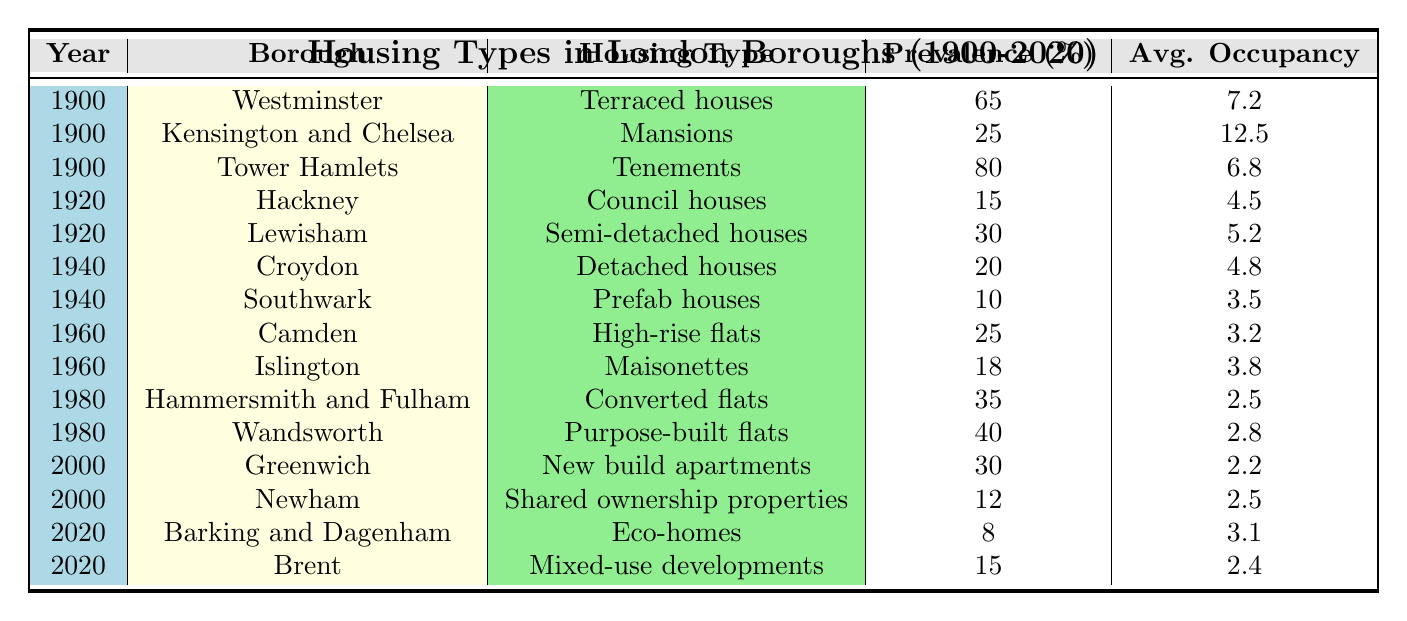What is the most prevalent housing type in Tower Hamlets in 1900? According to the table, in 1900, Tower Hamlets had a prevalence of 80% for Tenements, which is the highest value for that year.
Answer: Tenements In which year did Barking and Dagenham have its lowest prevalence of housing type? Observing the data, Barking and Dagenham has a prevalence of 8% for Eco-homes in 2020, which is the only value listed for that borough in that year, indicating it has not been previously recorded.
Answer: 2020 What is the average occupancy of council houses in Hackney in 1920? The table indicates that the average occupancy for council houses in Hackney in 1920 was 4.5.
Answer: 4.5 How many percentage points more prevalent were terraced houses in Westminster in 1900 compared to council houses in Hackney in 1920? The prevalence of terraced houses in Westminster was 65%, while council houses in Hackney had a prevalence of 15%. Therefore, 65 - 15 = 50 percentage points difference.
Answer: 50 Is it true that vacant properties in Camden had a higher occupancy than the average occupancy of detached houses in Croydon? The average occupancy of high-rise flats in Camden in 1960 is 3.2, while the average occupancy of detached houses in Croydon in 1940 is 4.8. Therefore, the statement is false as 3.2 < 4.8.
Answer: False What is the prevalence of eco-homes in Barking and Dagenham compared to the average occupancy of shared ownership properties in Newham? Barking and Dagenham has a prevalence of 8% for eco-homes, while Newham has an average occupancy of 2.5. Since we are comparing prevalence (a percentage) and occupancy (a number), we observe 8% for eco-homes and 2.5 for shared ownership properties.
Answer: 8% vs 2.5 Which borough had a higher average occupancy for housing types in 1900, Westminster or Kensington and Chelsea? Westminster had an average occupancy of 7.2 for terraced houses, while Kensington and Chelsea had an average occupancy of 12.5 for mansions. As 12.5 > 7.2, Kensington and Chelsea had a higher average occupancy.
Answer: Kensington and Chelsea Which London borough had the highest prevalence of a housing type in 1960? Camden had a prevalence of 25% for high-rise flats and Islington had 18% for maisonettes in 1960, making Camden the borough with the highest prevalence for that year.
Answer: Camden 